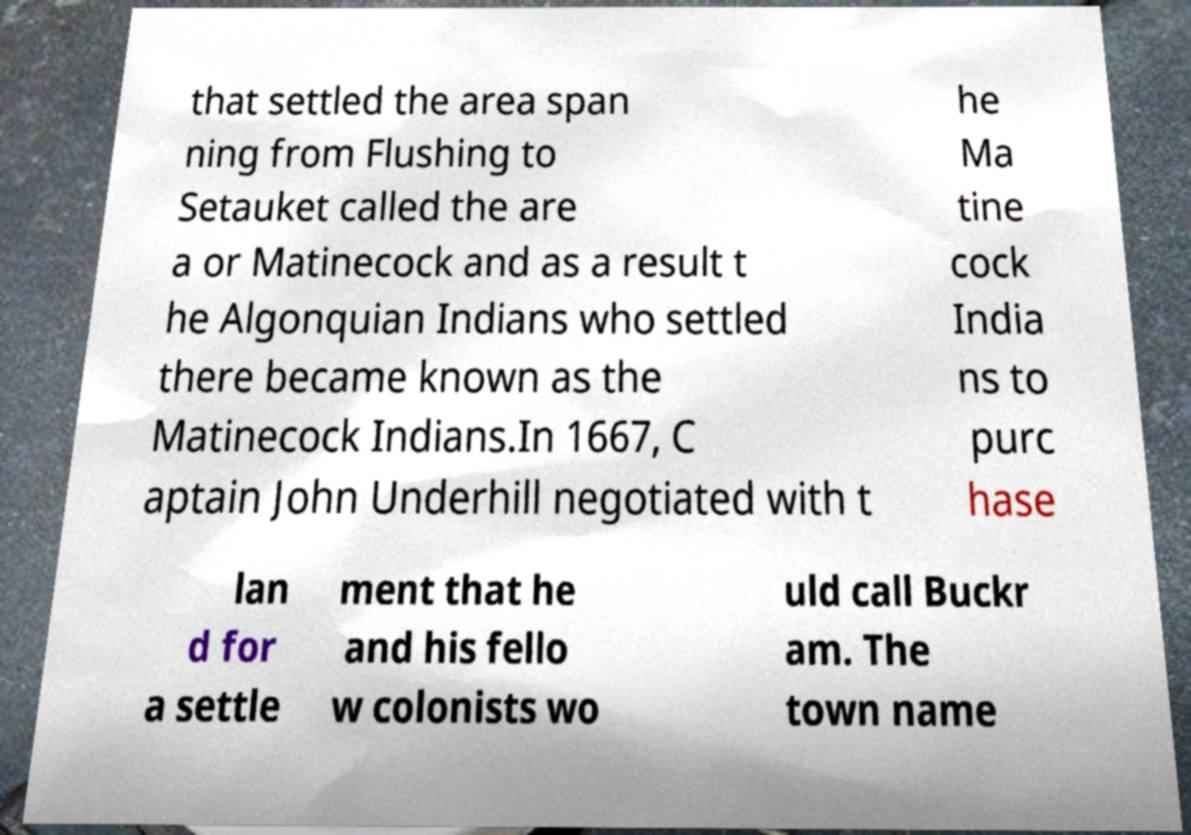For documentation purposes, I need the text within this image transcribed. Could you provide that? that settled the area span ning from Flushing to Setauket called the are a or Matinecock and as a result t he Algonquian Indians who settled there became known as the Matinecock Indians.In 1667, C aptain John Underhill negotiated with t he Ma tine cock India ns to purc hase lan d for a settle ment that he and his fello w colonists wo uld call Buckr am. The town name 